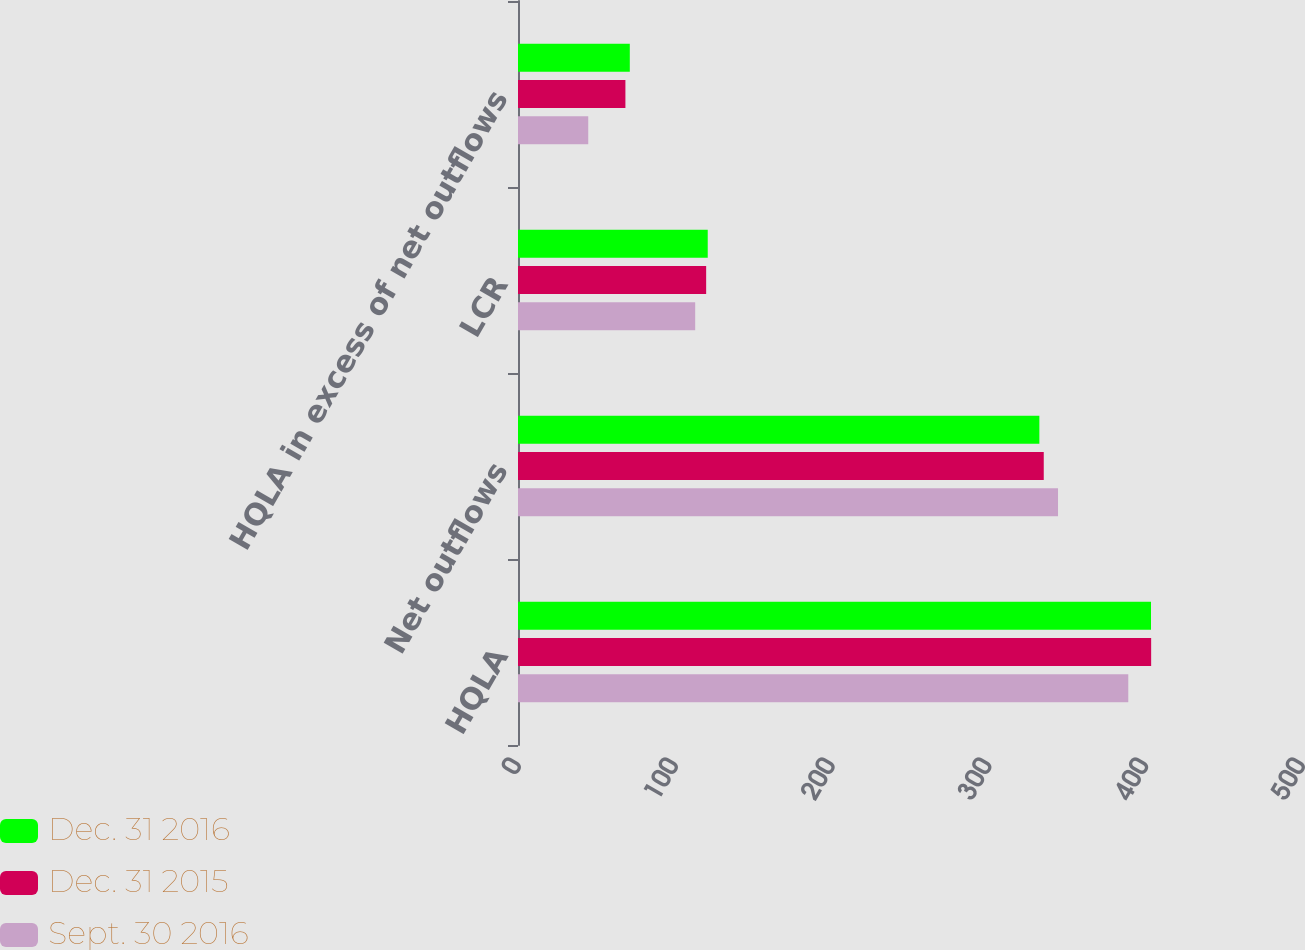Convert chart to OTSL. <chart><loc_0><loc_0><loc_500><loc_500><stacked_bar_chart><ecel><fcel>HQLA<fcel>Net outflows<fcel>LCR<fcel>HQLA in excess of net outflows<nl><fcel>Dec. 31 2016<fcel>403.7<fcel>332.5<fcel>121<fcel>71.3<nl><fcel>Dec. 31 2015<fcel>403.8<fcel>335.3<fcel>120<fcel>68.5<nl><fcel>Sept. 30 2016<fcel>389.2<fcel>344.4<fcel>113<fcel>44.8<nl></chart> 